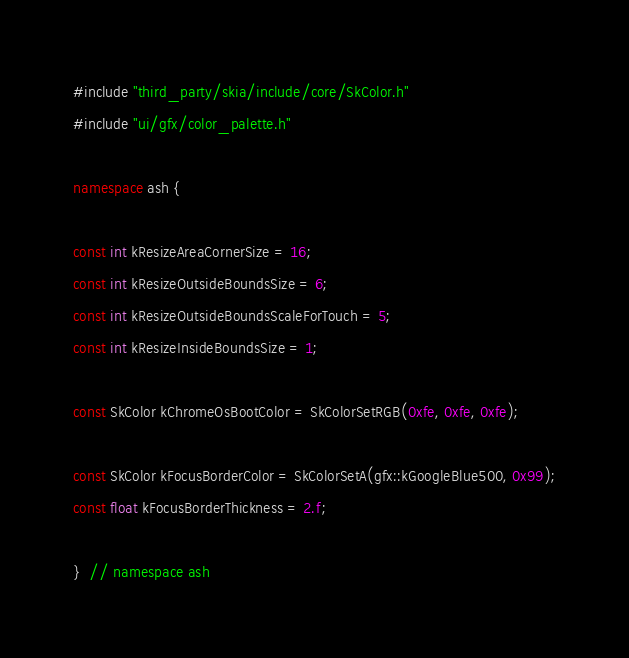Convert code to text. <code><loc_0><loc_0><loc_500><loc_500><_C++_>#include "third_party/skia/include/core/SkColor.h"
#include "ui/gfx/color_palette.h"

namespace ash {

const int kResizeAreaCornerSize = 16;
const int kResizeOutsideBoundsSize = 6;
const int kResizeOutsideBoundsScaleForTouch = 5;
const int kResizeInsideBoundsSize = 1;

const SkColor kChromeOsBootColor = SkColorSetRGB(0xfe, 0xfe, 0xfe);

const SkColor kFocusBorderColor = SkColorSetA(gfx::kGoogleBlue500, 0x99);
const float kFocusBorderThickness = 2.f;

}  // namespace ash
</code> 